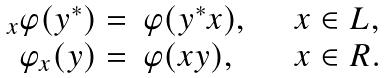Convert formula to latex. <formula><loc_0><loc_0><loc_500><loc_500>\begin{array} { r l l } _ { x } \varphi ( y ^ { \ast } ) = & \varphi ( y ^ { \ast } x ) , \quad & x \in L , \\ \varphi _ { x } ( y ) = & \varphi ( x y ) , & x \in R . \end{array}</formula> 